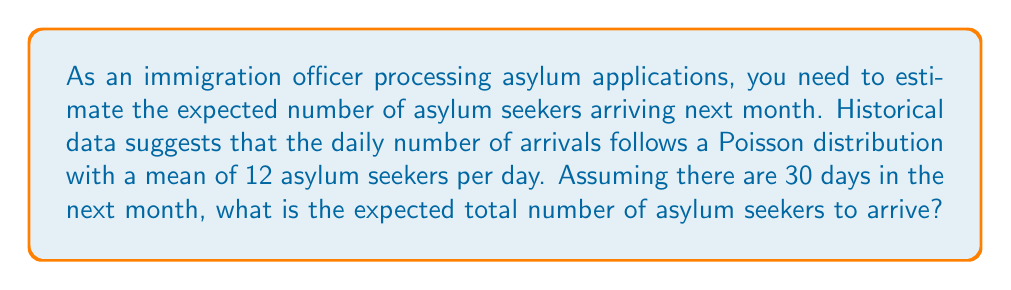What is the answer to this math problem? To solve this problem, we need to understand the properties of the Poisson distribution and how to calculate the expected value for a sum of random variables.

1. Poisson Distribution:
   The Poisson distribution is often used to model the number of events occurring in a fixed interval of time or space. In this case, it models the number of asylum seekers arriving per day.

2. Expected Value of Poisson Distribution:
   For a Poisson distribution with parameter $\lambda$, the expected value is equal to $\lambda$. In this case, $\lambda = 12$ asylum seekers per day.

3. Sum of Independent Poisson Random Variables:
   A key property of the Poisson distribution is that the sum of independent Poisson random variables is also Poisson distributed. The parameter of the resulting distribution is the sum of the individual parameters.

4. Calculating the Expected Value:
   Let $X_i$ be the number of asylum seekers arriving on day $i$, where $i = 1, 2, ..., 30$.
   Each $X_i$ follows a Poisson distribution with $\lambda = 12$.

   The total number of asylum seekers in the month, $Y$, is:
   $$Y = X_1 + X_2 + ... + X_{30}$$

   Since the $X_i$ are independent and identically distributed, $Y$ follows a Poisson distribution with parameter:
   $$\lambda_Y = 30 \cdot 12 = 360$$

5. Expected Value of Y:
   The expected value of $Y$ is equal to its Poisson parameter:
   $$E[Y] = \lambda_Y = 360$$

Therefore, the expected total number of asylum seekers to arrive in the next month is 360.
Answer: 360 asylum seekers 